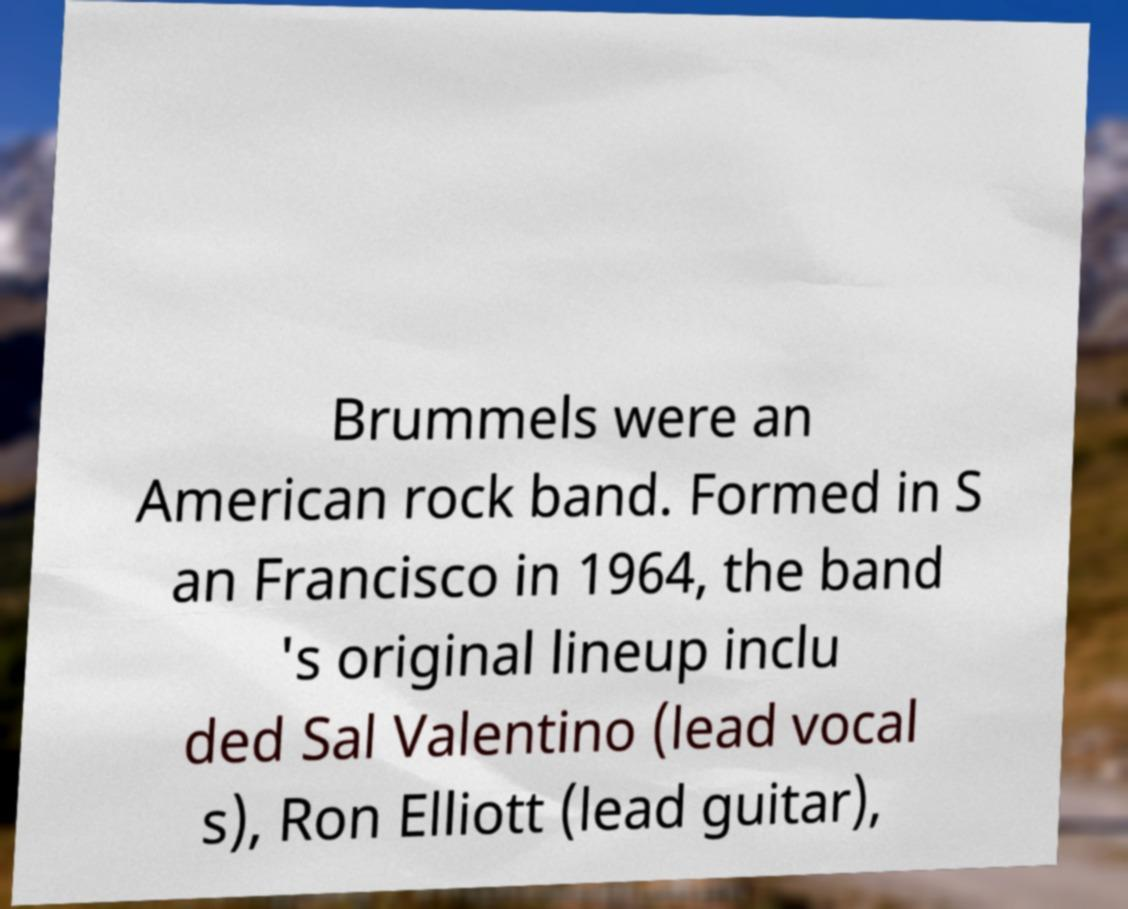Can you read and provide the text displayed in the image?This photo seems to have some interesting text. Can you extract and type it out for me? Brummels were an American rock band. Formed in S an Francisco in 1964, the band 's original lineup inclu ded Sal Valentino (lead vocal s), Ron Elliott (lead guitar), 